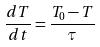Convert formula to latex. <formula><loc_0><loc_0><loc_500><loc_500>\frac { d T } { d t } = \frac { T _ { 0 } - T } { \tau }</formula> 